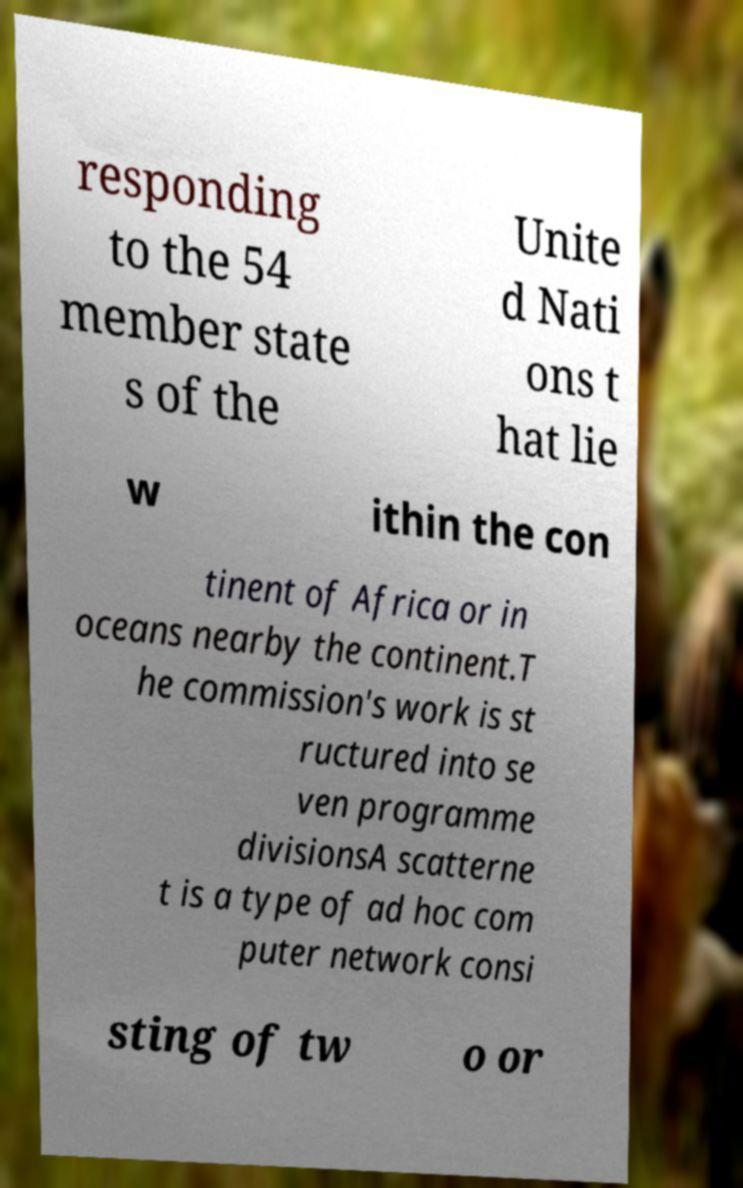Please identify and transcribe the text found in this image. responding to the 54 member state s of the Unite d Nati ons t hat lie w ithin the con tinent of Africa or in oceans nearby the continent.T he commission's work is st ructured into se ven programme divisionsA scatterne t is a type of ad hoc com puter network consi sting of tw o or 